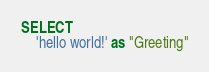Convert code to text. <code><loc_0><loc_0><loc_500><loc_500><_SQL_>SELECT
    'hello world!' as "Greeting"</code> 